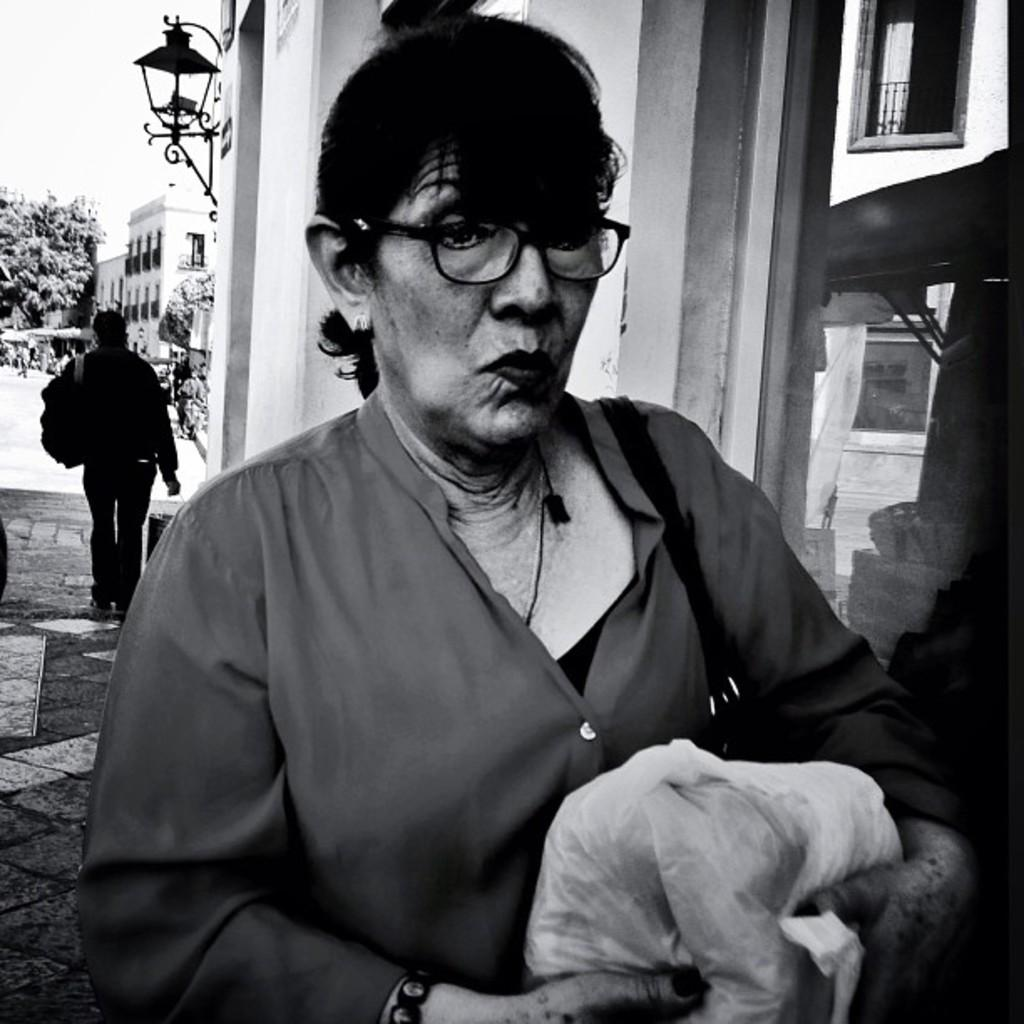How many people are present in the image? There are two people in the image. What can be seen in the background of the image? There are buildings and trees in the background of the image. What is the color scheme of the image? The image is in black and white color. What type of produce is being harvested by the boys in the image? There are no boys present in the image, and no produce is being harvested. 